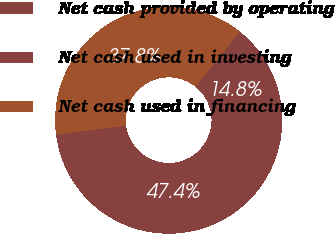Convert chart. <chart><loc_0><loc_0><loc_500><loc_500><pie_chart><fcel>Net cash provided by operating<fcel>Net cash used in investing<fcel>Net cash used in financing<nl><fcel>47.4%<fcel>14.79%<fcel>37.82%<nl></chart> 